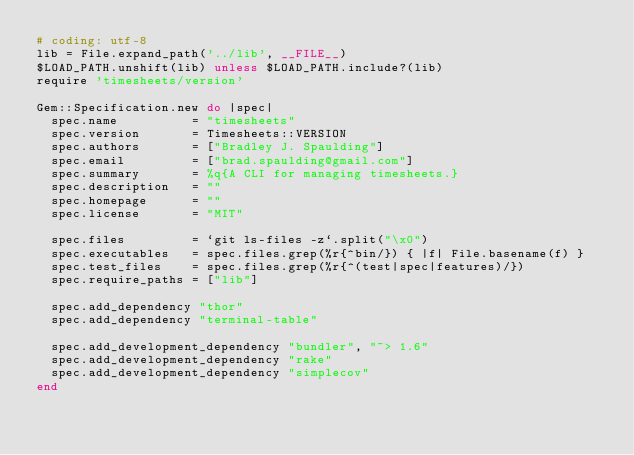<code> <loc_0><loc_0><loc_500><loc_500><_Ruby_># coding: utf-8
lib = File.expand_path('../lib', __FILE__)
$LOAD_PATH.unshift(lib) unless $LOAD_PATH.include?(lib)
require 'timesheets/version'

Gem::Specification.new do |spec|
  spec.name          = "timesheets"
  spec.version       = Timesheets::VERSION
  spec.authors       = ["Bradley J. Spaulding"]
  spec.email         = ["brad.spaulding@gmail.com"]
  spec.summary       = %q{A CLI for managing timesheets.}
  spec.description   = ""
  spec.homepage      = ""
  spec.license       = "MIT"

  spec.files         = `git ls-files -z`.split("\x0")
  spec.executables   = spec.files.grep(%r{^bin/}) { |f| File.basename(f) }
  spec.test_files    = spec.files.grep(%r{^(test|spec|features)/})
  spec.require_paths = ["lib"]

  spec.add_dependency "thor"
  spec.add_dependency "terminal-table"

  spec.add_development_dependency "bundler", "~> 1.6"
  spec.add_development_dependency "rake"
  spec.add_development_dependency "simplecov"
end
</code> 